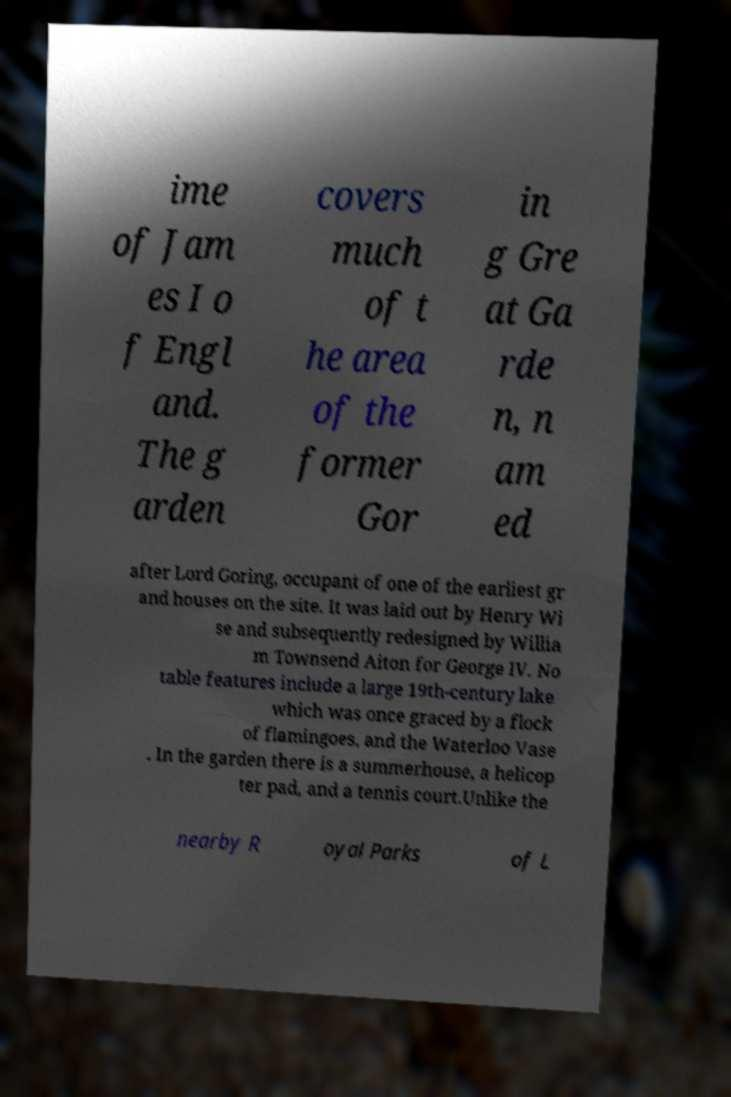Could you extract and type out the text from this image? ime of Jam es I o f Engl and. The g arden covers much of t he area of the former Gor in g Gre at Ga rde n, n am ed after Lord Goring, occupant of one of the earliest gr and houses on the site. It was laid out by Henry Wi se and subsequently redesigned by Willia m Townsend Aiton for George IV. No table features include a large 19th-century lake which was once graced by a flock of flamingoes, and the Waterloo Vase . In the garden there is a summerhouse, a helicop ter pad, and a tennis court.Unlike the nearby R oyal Parks of L 